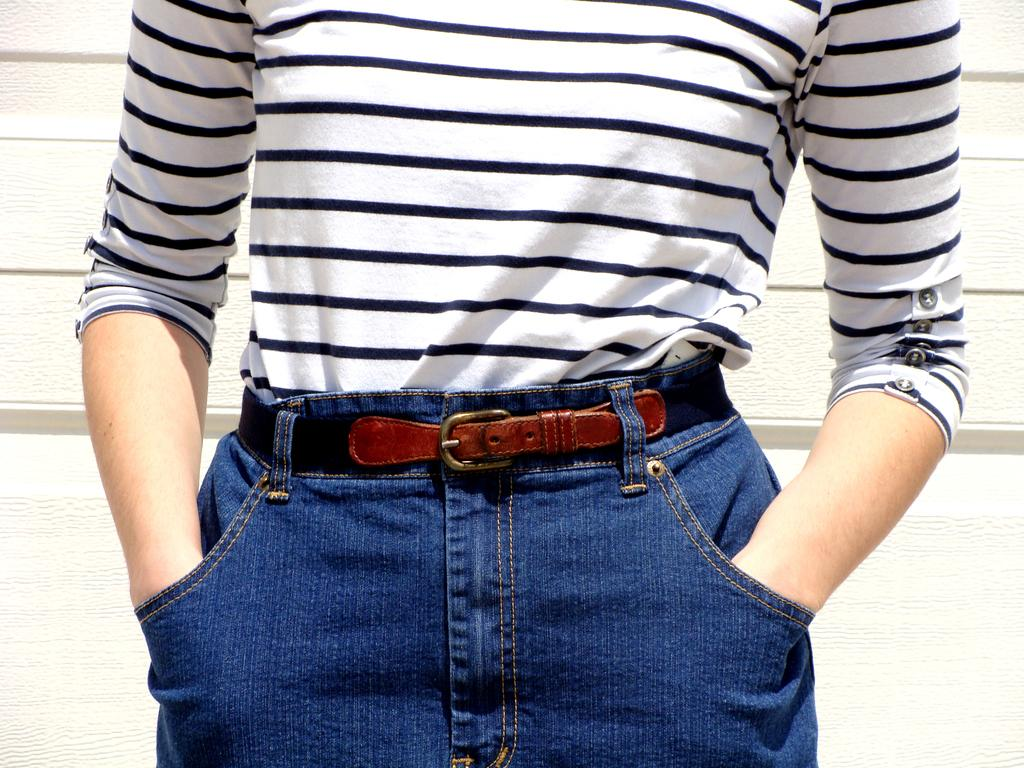What is the main subject of the image? There is a person in the image. What is the person wearing on their upper body? The person is wearing a white t-shirt. What is the person wearing on their lower body? The person is wearing blue jeans. What can be seen behind the person? There is a wall behind the person. Can you see the person's brother in the image? There is no mention of a brother in the image, so it cannot be determined if the person's brother is present. What is the person's tongue doing in the image? There is no indication of the person's tongue in the image, so it cannot be described. 